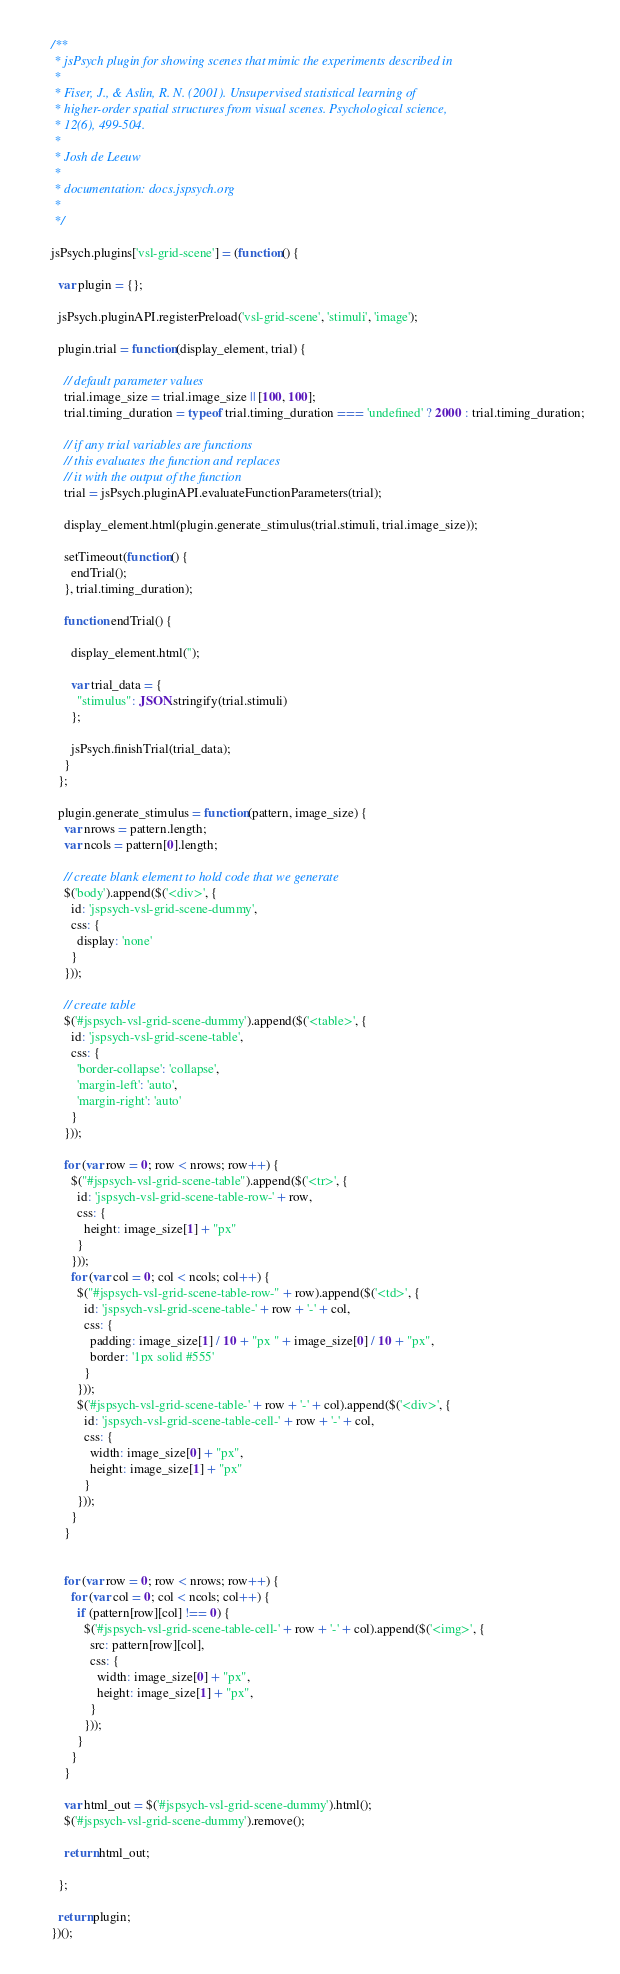Convert code to text. <code><loc_0><loc_0><loc_500><loc_500><_JavaScript_>/**
 * jsPsych plugin for showing scenes that mimic the experiments described in
 *
 * Fiser, J., & Aslin, R. N. (2001). Unsupervised statistical learning of
 * higher-order spatial structures from visual scenes. Psychological science,
 * 12(6), 499-504.
 *
 * Josh de Leeuw
 *
 * documentation: docs.jspsych.org
 *
 */

jsPsych.plugins['vsl-grid-scene'] = (function() {

  var plugin = {};

  jsPsych.pluginAPI.registerPreload('vsl-grid-scene', 'stimuli', 'image');

  plugin.trial = function(display_element, trial) {

    // default parameter values
    trial.image_size = trial.image_size || [100, 100];
    trial.timing_duration = typeof trial.timing_duration === 'undefined' ? 2000 : trial.timing_duration;

    // if any trial variables are functions
    // this evaluates the function and replaces
    // it with the output of the function
    trial = jsPsych.pluginAPI.evaluateFunctionParameters(trial);

    display_element.html(plugin.generate_stimulus(trial.stimuli, trial.image_size));

    setTimeout(function() {
      endTrial();
    }, trial.timing_duration);

    function endTrial() {

      display_element.html('');

      var trial_data = {
        "stimulus": JSON.stringify(trial.stimuli)
      };

      jsPsych.finishTrial(trial_data);
    }
  };

  plugin.generate_stimulus = function(pattern, image_size) {
    var nrows = pattern.length;
    var ncols = pattern[0].length;

    // create blank element to hold code that we generate
    $('body').append($('<div>', {
      id: 'jspsych-vsl-grid-scene-dummy',
      css: {
        display: 'none'
      }
    }));

    // create table
    $('#jspsych-vsl-grid-scene-dummy').append($('<table>', {
      id: 'jspsych-vsl-grid-scene-table',
      css: {
        'border-collapse': 'collapse',
        'margin-left': 'auto',
        'margin-right': 'auto'
      }
    }));

    for (var row = 0; row < nrows; row++) {
      $("#jspsych-vsl-grid-scene-table").append($('<tr>', {
        id: 'jspsych-vsl-grid-scene-table-row-' + row,
        css: {
          height: image_size[1] + "px"
        }
      }));
      for (var col = 0; col < ncols; col++) {
        $("#jspsych-vsl-grid-scene-table-row-" + row).append($('<td>', {
          id: 'jspsych-vsl-grid-scene-table-' + row + '-' + col,
          css: {
            padding: image_size[1] / 10 + "px " + image_size[0] / 10 + "px",
            border: '1px solid #555'
          }
        }));
        $('#jspsych-vsl-grid-scene-table-' + row + '-' + col).append($('<div>', {
          id: 'jspsych-vsl-grid-scene-table-cell-' + row + '-' + col,
          css: {
            width: image_size[0] + "px",
            height: image_size[1] + "px"
          }
        }));
      }
    }


    for (var row = 0; row < nrows; row++) {
      for (var col = 0; col < ncols; col++) {
        if (pattern[row][col] !== 0) {
          $('#jspsych-vsl-grid-scene-table-cell-' + row + '-' + col).append($('<img>', {
            src: pattern[row][col],
            css: {
              width: image_size[0] + "px",
              height: image_size[1] + "px",
            }
          }));
        }
      }
    }

    var html_out = $('#jspsych-vsl-grid-scene-dummy').html();
    $('#jspsych-vsl-grid-scene-dummy').remove();

    return html_out;

  };

  return plugin;
})();
</code> 